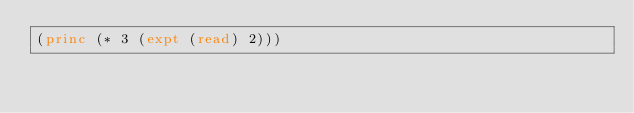Convert code to text. <code><loc_0><loc_0><loc_500><loc_500><_Lisp_>(princ (* 3 (expt (read) 2)))</code> 